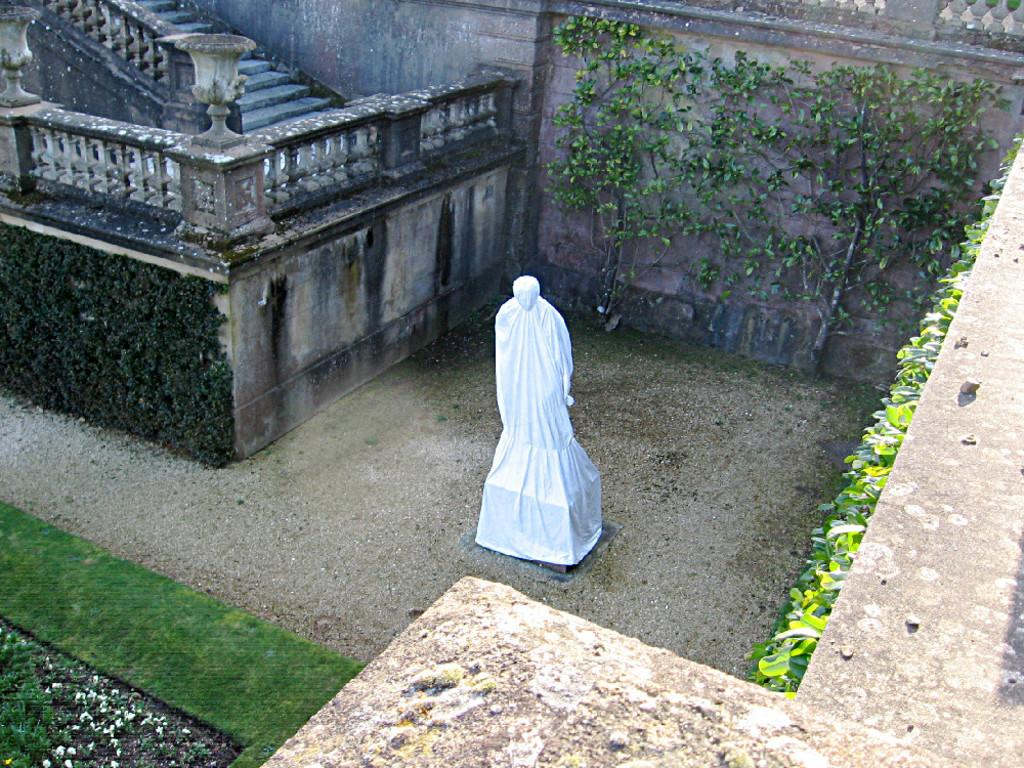What is the main subject in the center of the image? There is a statue in the center of the image. What is the condition of the statue in the image? The statue is covered with a cloth. What type of structure can be seen in the image? There is a building with a staircase in the image. What type of vegetation is present on the building? There are plants on the walls of the building. What type of ground surface is visible in the image? There is grass visible in the image. What type of silk is being used to jump over the current in the image? There is no silk, jumping, or current present in the image. 